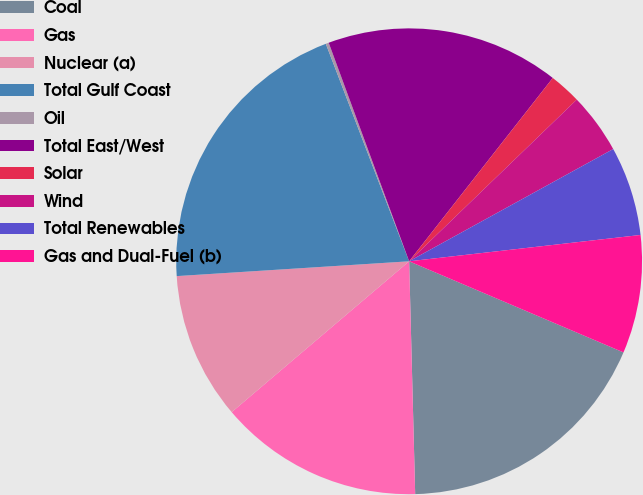Convert chart. <chart><loc_0><loc_0><loc_500><loc_500><pie_chart><fcel>Coal<fcel>Gas<fcel>Nuclear (a)<fcel>Total Gulf Coast<fcel>Oil<fcel>Total East/West<fcel>Solar<fcel>Wind<fcel>Total Renewables<fcel>Gas and Dual-Fuel (b)<nl><fcel>18.19%<fcel>14.2%<fcel>10.2%<fcel>20.19%<fcel>0.21%<fcel>16.19%<fcel>2.21%<fcel>4.21%<fcel>6.2%<fcel>8.2%<nl></chart> 